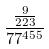Convert formula to latex. <formula><loc_0><loc_0><loc_500><loc_500>\frac { \frac { 9 } { 2 2 3 } } { 7 7 ^ { 4 5 5 } }</formula> 